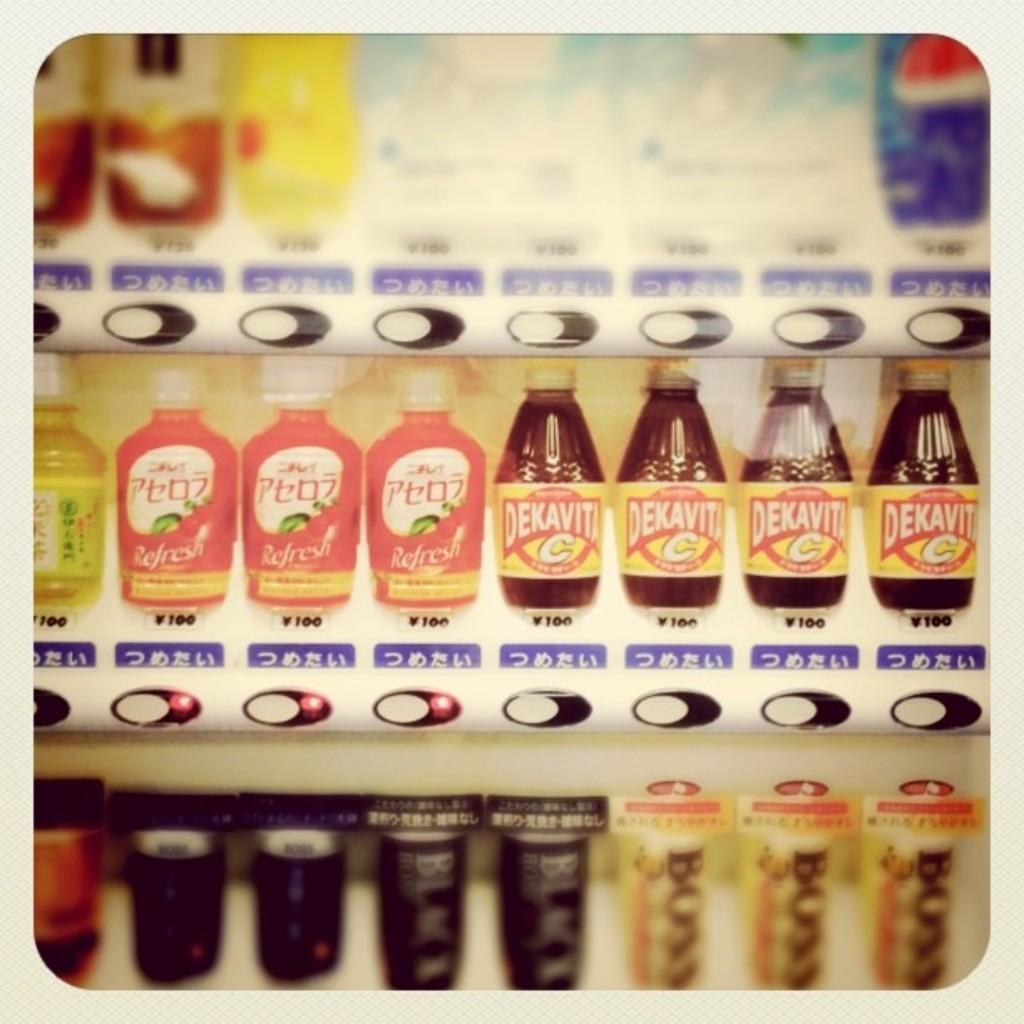What objects can be seen in the image? There are multiple bottles in the image. Are there any distinguishing features on the bottles? Yes, there are stickers on the bottles. Where are the bottles located? The bottles are placed on an iron shelf. What type of square celery can be seen on the iron shelf in the image? There is no celery present in the image, and celery is not typically square in shape. 